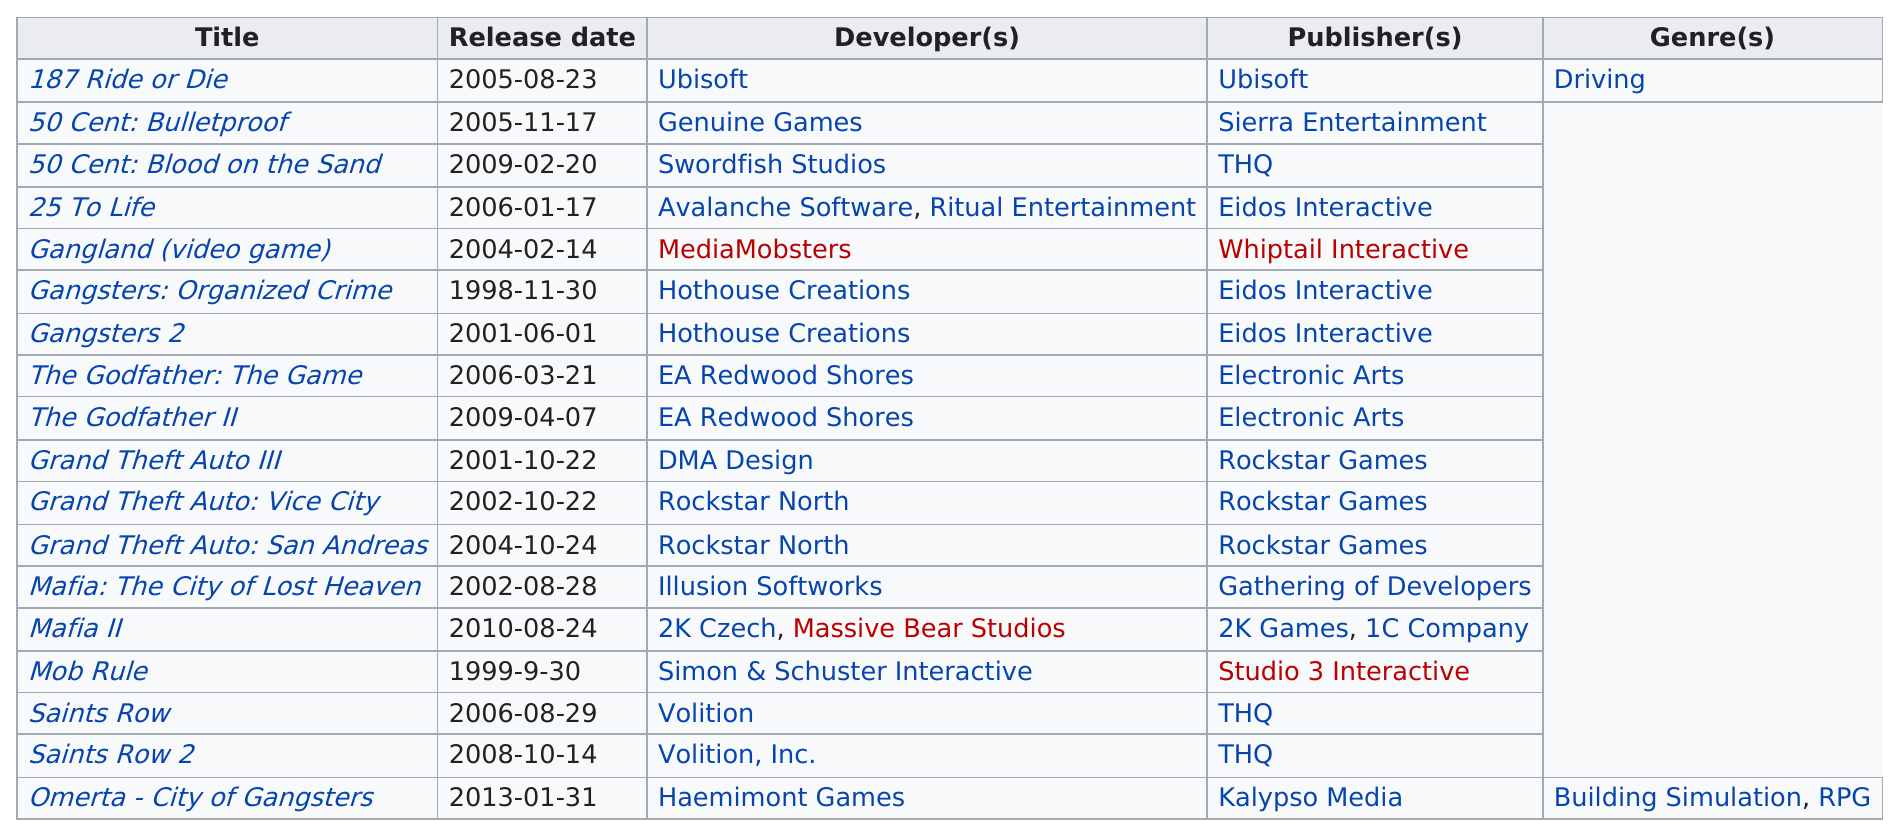Identify some key points in this picture. As of my knowledge cutoff date in September 2021, a total of 18 gangster games have been released. 187 Ride or Die was the only game that had only the driving genre. There have been two gangster-themed video games developed by Rockstar North. At least three Grand Theft Auto games are listed. Mob Rule is older than 25 to Life. 